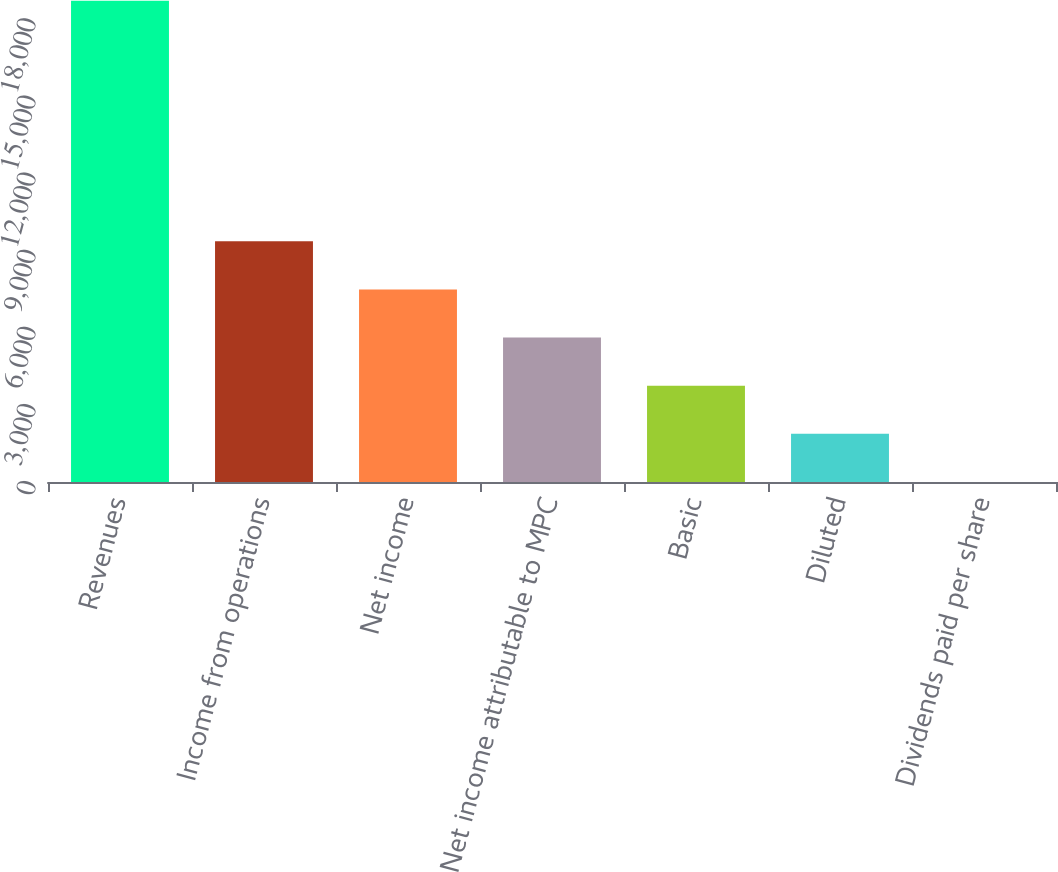Convert chart. <chart><loc_0><loc_0><loc_500><loc_500><bar_chart><fcel>Revenues<fcel>Income from operations<fcel>Net income<fcel>Net income attributable to MPC<fcel>Basic<fcel>Diluted<fcel>Dividends paid per share<nl><fcel>18716<fcel>9358.17<fcel>7486.6<fcel>5615.03<fcel>3743.46<fcel>1871.89<fcel>0.32<nl></chart> 